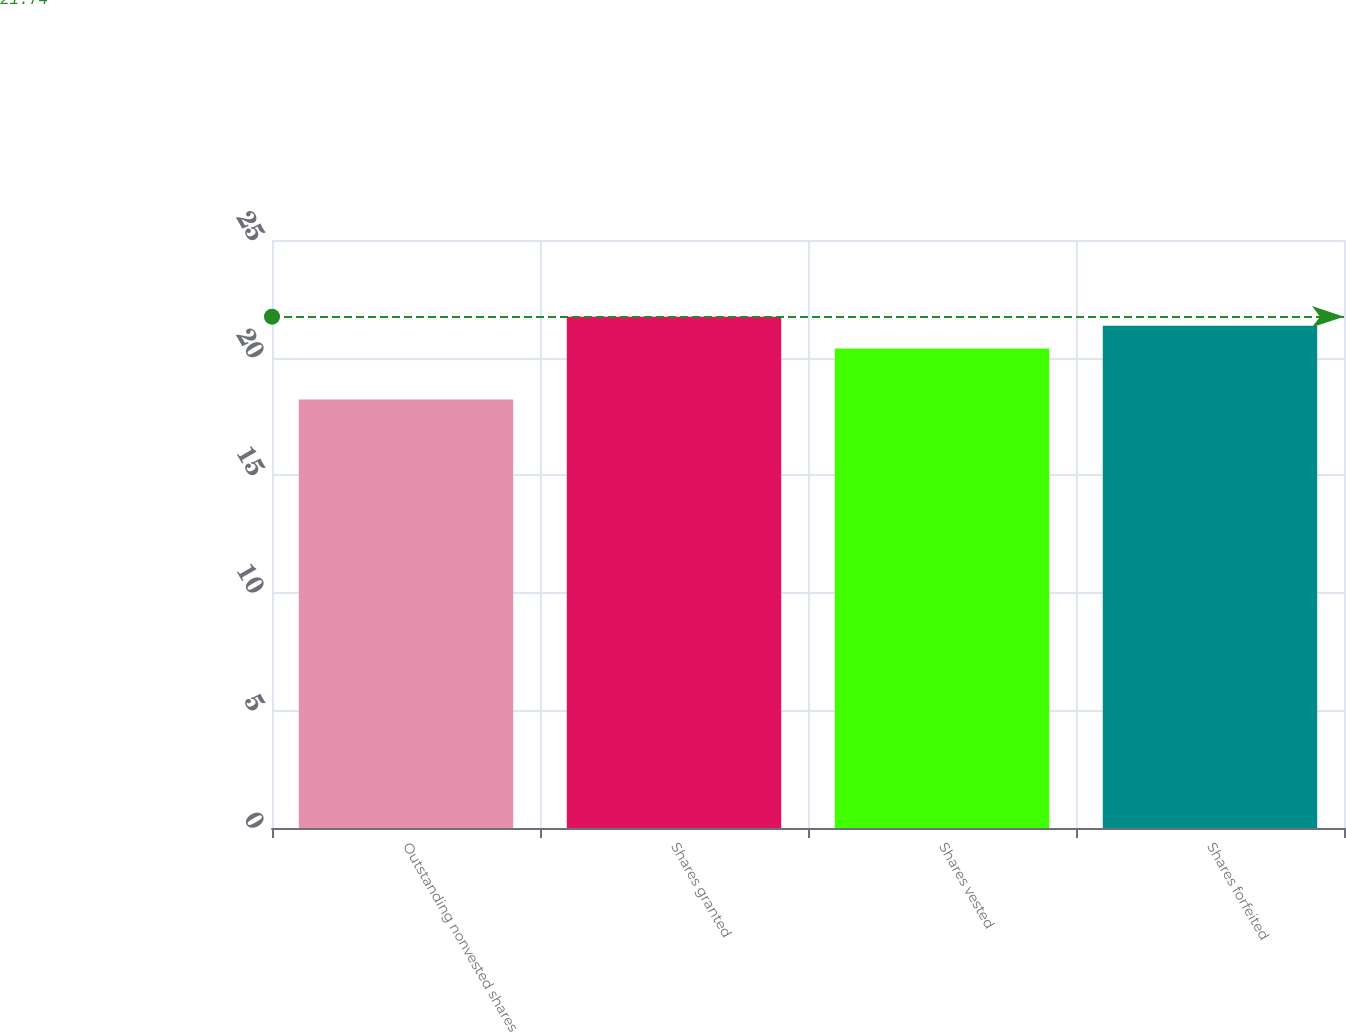Convert chart. <chart><loc_0><loc_0><loc_500><loc_500><bar_chart><fcel>Outstanding nonvested shares<fcel>Shares granted<fcel>Shares vested<fcel>Shares forfeited<nl><fcel>18.22<fcel>21.74<fcel>20.39<fcel>21.35<nl></chart> 